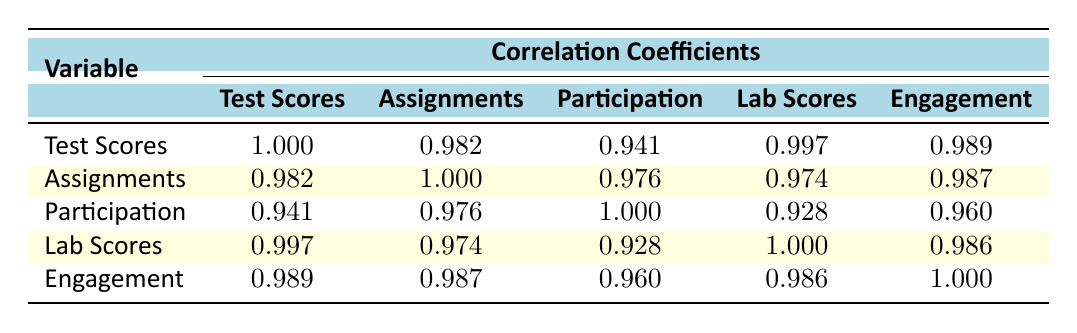What is the correlation coefficient between test scores and engagement? From the table, we can see that the correlation coefficient between test scores and engagement is 0.989.
Answer: 0.989 Which variable has the highest correlation with lab scores? Looking at the table, the highest correlation with lab scores is with test scores, which has a coefficient of 0.997.
Answer: 0.997 What are the correlation coefficients between assignments completed and class participation? The correlation coefficient between assignments completed and class participation is 0.976 according to the table.
Answer: 0.976 Is the correlation between class participation and lab scores greater than 0.9? Yes, the correlation coefficient between class participation and lab scores is 0.928, which is indeed greater than 0.9.
Answer: Yes What is the average correlation coefficient for engagement with other metrics? The correlations for engagement are: with test scores (0.989), assignments (0.987), participation (0.960), and lab scores (0.986). Adding these up gives: 0.989 + 0.987 + 0.960 + 0.986 = 3.922, and dividing by 4 (the number of correlations) gives an average of 0.9805.
Answer: 0.9805 Which student performance metric has the second highest correlation with engagement? The correlation coefficient for assignments completed with engagement is 0.987, which is the second highest after test scores (0.989).
Answer: 0.987 